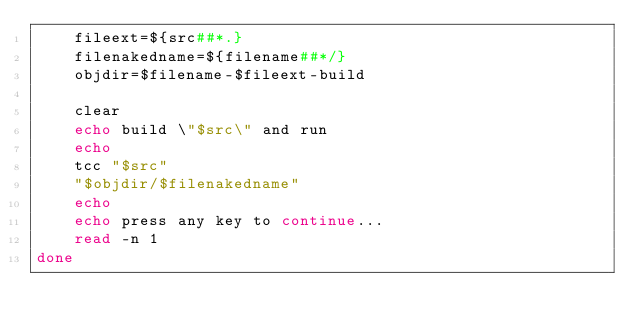Convert code to text. <code><loc_0><loc_0><loc_500><loc_500><_Bash_>	fileext=${src##*.}
	filenakedname=${filename##*/}
	objdir=$filename-$fileext-build

	clear
	echo build \"$src\" and run
	echo
	tcc "$src"
	"$objdir/$filenakedname"
	echo
	echo press any key to continue...
	read -n 1
done
</code> 